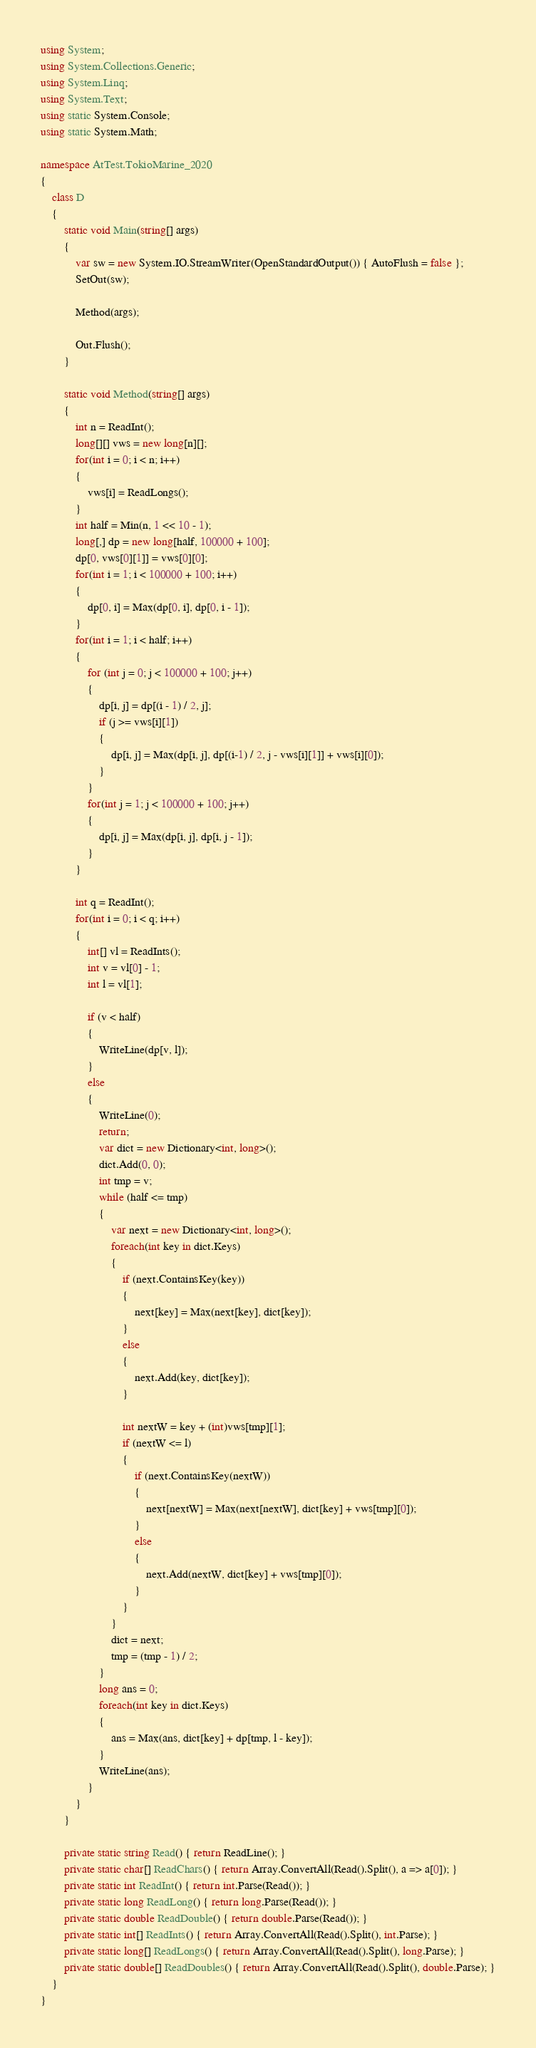Convert code to text. <code><loc_0><loc_0><loc_500><loc_500><_C#_>using System;
using System.Collections.Generic;
using System.Linq;
using System.Text;
using static System.Console;
using static System.Math;

namespace AtTest.TokioMarine_2020
{
    class D
    {
        static void Main(string[] args)
        {
            var sw = new System.IO.StreamWriter(OpenStandardOutput()) { AutoFlush = false };
            SetOut(sw);

            Method(args);

            Out.Flush();
        }

        static void Method(string[] args)
        {
            int n = ReadInt();
            long[][] vws = new long[n][];
            for(int i = 0; i < n; i++)
            {
                vws[i] = ReadLongs();
            }
            int half = Min(n, 1 << 10 - 1);
            long[,] dp = new long[half, 100000 + 100];
            dp[0, vws[0][1]] = vws[0][0];
            for(int i = 1; i < 100000 + 100; i++)
            {
                dp[0, i] = Max(dp[0, i], dp[0, i - 1]);
            }
            for(int i = 1; i < half; i++)
            {
                for (int j = 0; j < 100000 + 100; j++)
                {
                    dp[i, j] = dp[(i - 1) / 2, j];
                    if (j >= vws[i][1])
                    {
                        dp[i, j] = Max(dp[i, j], dp[(i-1) / 2, j - vws[i][1]] + vws[i][0]);
                    }
                }
                for(int j = 1; j < 100000 + 100; j++)
                {
                    dp[i, j] = Max(dp[i, j], dp[i, j - 1]);
                }
            }

            int q = ReadInt();
            for(int i = 0; i < q; i++)
            {
                int[] vl = ReadInts();
                int v = vl[0] - 1;
                int l = vl[1];

                if (v < half)
                {
                    WriteLine(dp[v, l]);
                }
                else
                {
                    WriteLine(0);
                    return;
                    var dict = new Dictionary<int, long>();
                    dict.Add(0, 0);
                    int tmp = v;
                    while (half <= tmp)
                    {
                        var next = new Dictionary<int, long>();
                        foreach(int key in dict.Keys)
                        {
                            if (next.ContainsKey(key))
                            {
                                next[key] = Max(next[key], dict[key]);
                            }
                            else
                            {
                                next.Add(key, dict[key]);
                            }

                            int nextW = key + (int)vws[tmp][1];
                            if (nextW <= l)
                            {
                                if (next.ContainsKey(nextW))
                                {
                                    next[nextW] = Max(next[nextW], dict[key] + vws[tmp][0]);
                                }
                                else
                                {
                                    next.Add(nextW, dict[key] + vws[tmp][0]);
                                }
                            }
                        }
                        dict = next;
                        tmp = (tmp - 1) / 2;
                    }
                    long ans = 0;
                    foreach(int key in dict.Keys)
                    {
                        ans = Max(ans, dict[key] + dp[tmp, l - key]);
                    }
                    WriteLine(ans);
                }
            }
        }

        private static string Read() { return ReadLine(); }
        private static char[] ReadChars() { return Array.ConvertAll(Read().Split(), a => a[0]); }
        private static int ReadInt() { return int.Parse(Read()); }
        private static long ReadLong() { return long.Parse(Read()); }
        private static double ReadDouble() { return double.Parse(Read()); }
        private static int[] ReadInts() { return Array.ConvertAll(Read().Split(), int.Parse); }
        private static long[] ReadLongs() { return Array.ConvertAll(Read().Split(), long.Parse); }
        private static double[] ReadDoubles() { return Array.ConvertAll(Read().Split(), double.Parse); }
    }
}
</code> 